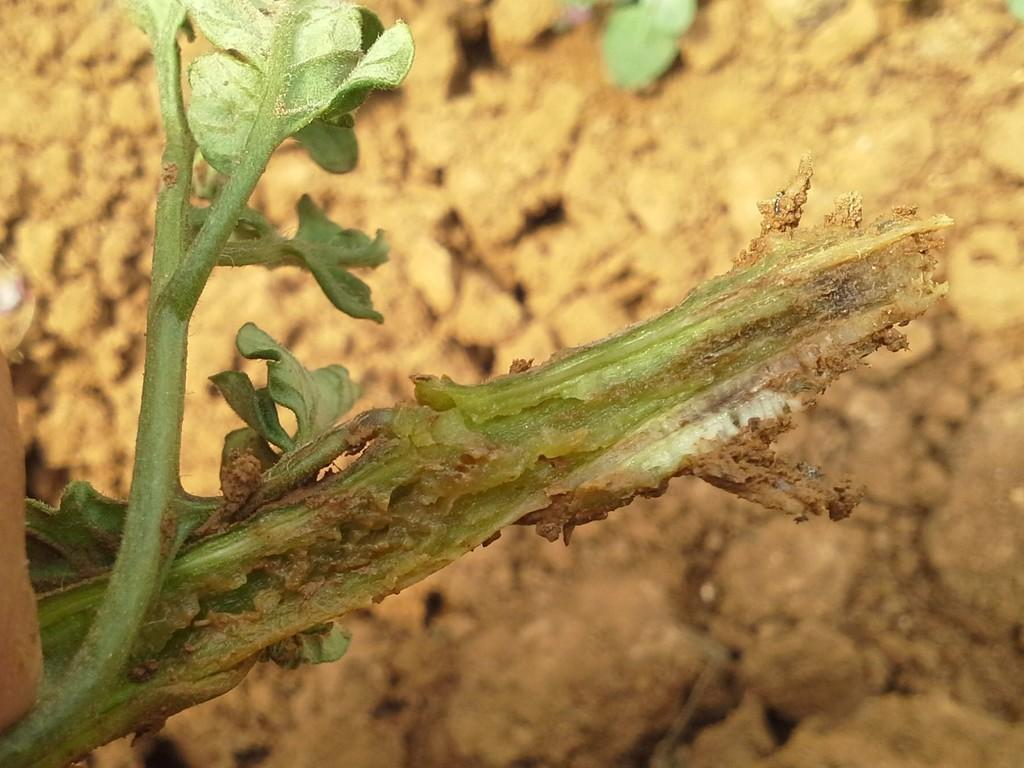Describe this image in one or two sentences. In this image we can see the plant and the background of the image is blurred. 